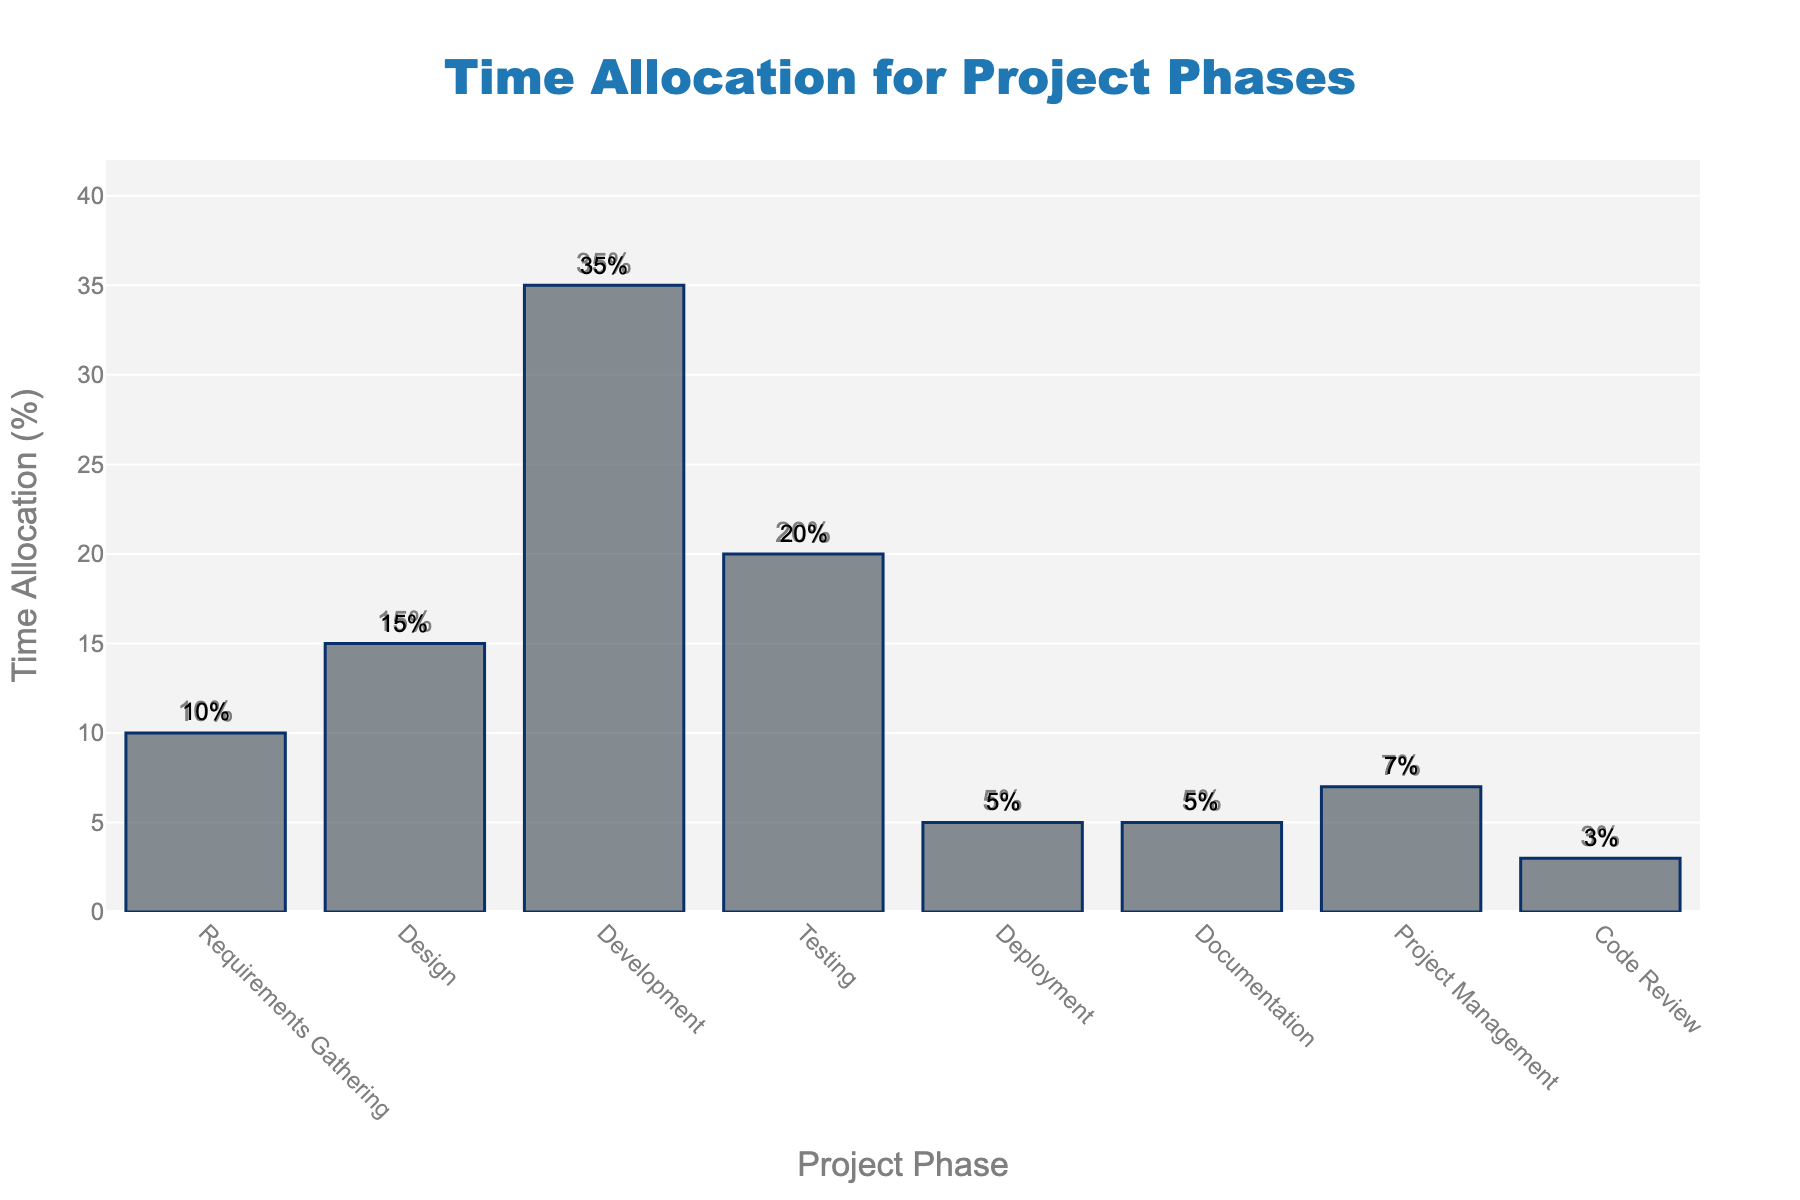Which phase takes up the most time in the project? The tallest bar on the chart represents the phase with the highest percentage. The 'Development' phase is the tallest, indicating it takes the most time.
Answer: Development Which project phases have the same time allocation? By comparing the bar heights and their corresponding percentages, 'Deployment' and 'Documentation' both have the same height of 5%.
Answer: Deployment and Documentation What is the total time allocated to 'Testing' and 'Code Review' phases? Add the percentages of the 'Testing' and 'Code Review' phases: 20% + 3% = 23%.
Answer: 23% How much more time is allocated to 'Project Management' than 'Code Review'? Subtract the percentage of 'Code Review' from 'Project Management': 7% - 3% = 4%.
Answer: 4% Is 'Design' allocated more time than 'Requirements Gathering'? If so, by how much? Compare the percentages of 'Design' and 'Requirements Gathering': 15% - 10% = 5%.
Answer: Yes, by 5% How many phases have a time allocation greater than 15%? By examining the bar heights, 'Development' (35%) and 'Testing' (20%) are the only phases above 15%.
Answer: 2 Which phase has the smallest time allocation? The shortest bar represents the phase with the smallest percentage, which is 'Code Review' at 3%.
Answer: Code Review What is the average time allocation across all phases? Sum all percentages and divide by the number of phases. (10+15+35+20+5+5+7+3) / 8 = 100 / 8 = 12.5%.
Answer: 12.5% What is the difference in time allocation between the 'Testing' and 'Development' phases? Subtract the percentage of 'Testing' from 'Development': 35% - 20% = 15%.
Answer: 15% Which phases have time allocations less than 10%? By checking the bar heights, 'Deployment' (5%), 'Documentation' (5%), and 'Code Review' (3%) are less than 10%.
Answer: Deployment, Documentation, and Code Review 